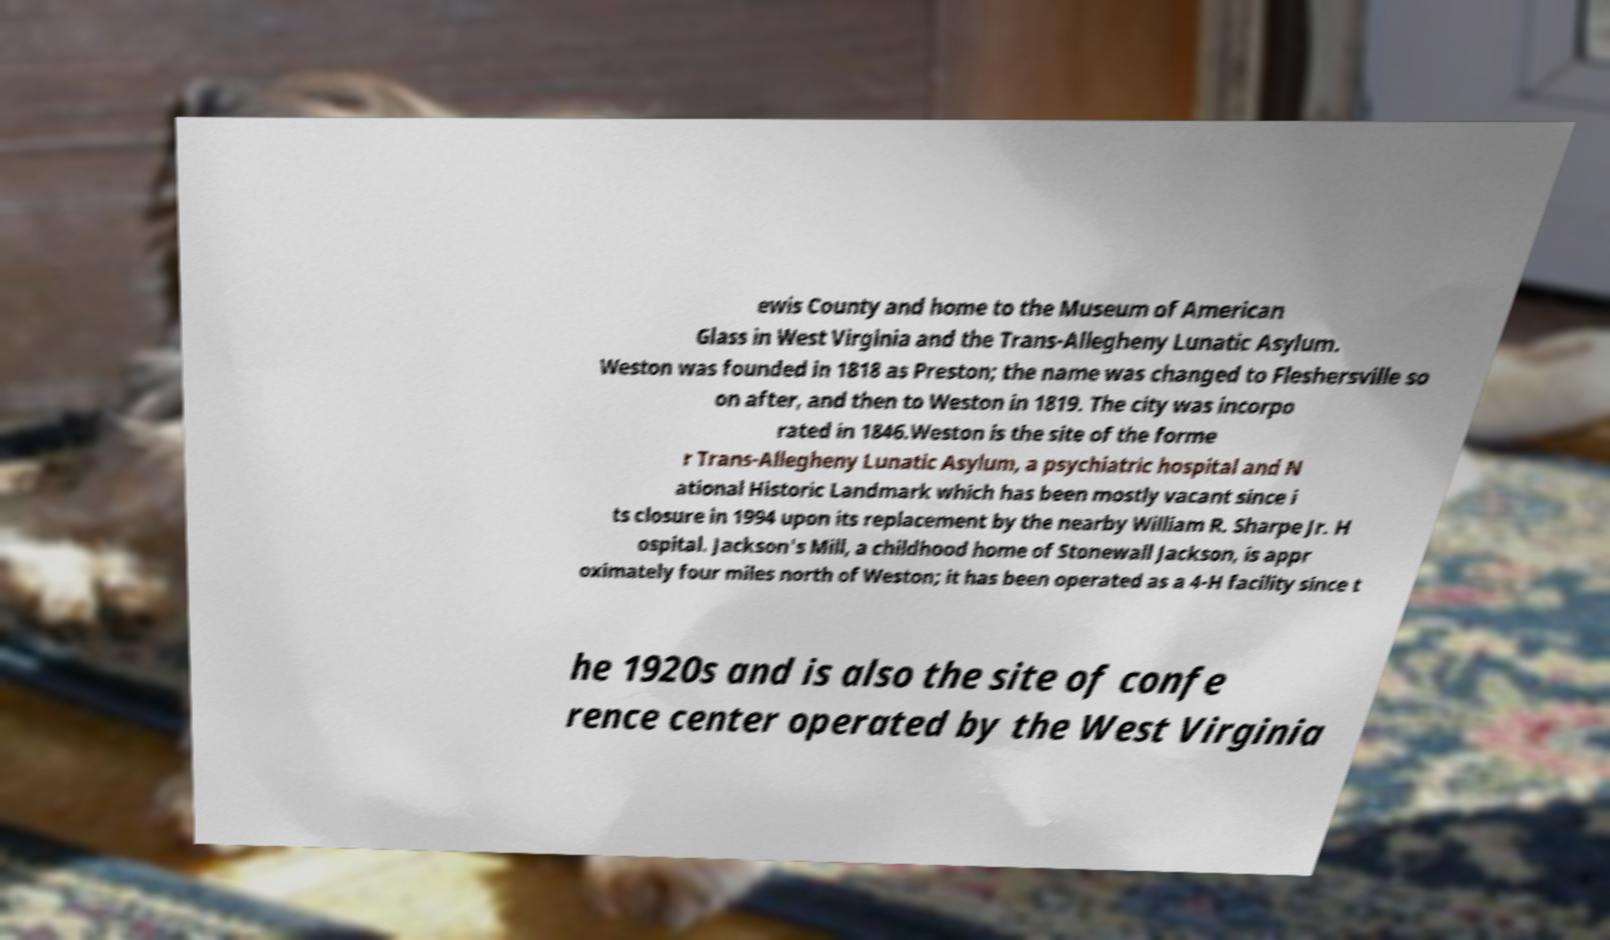There's text embedded in this image that I need extracted. Can you transcribe it verbatim? ewis County and home to the Museum of American Glass in West Virginia and the Trans-Allegheny Lunatic Asylum. Weston was founded in 1818 as Preston; the name was changed to Fleshersville so on after, and then to Weston in 1819. The city was incorpo rated in 1846.Weston is the site of the forme r Trans-Allegheny Lunatic Asylum, a psychiatric hospital and N ational Historic Landmark which has been mostly vacant since i ts closure in 1994 upon its replacement by the nearby William R. Sharpe Jr. H ospital. Jackson's Mill, a childhood home of Stonewall Jackson, is appr oximately four miles north of Weston; it has been operated as a 4-H facility since t he 1920s and is also the site of confe rence center operated by the West Virginia 